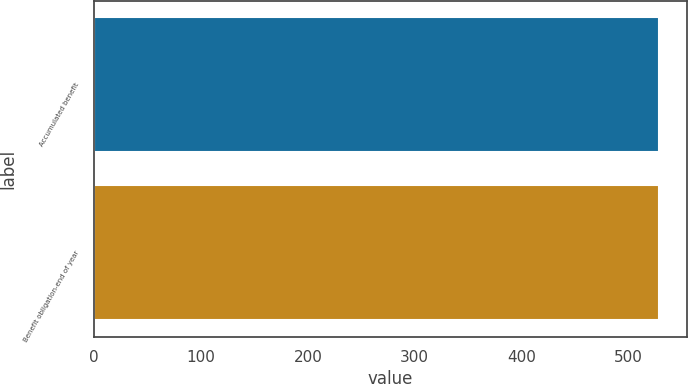<chart> <loc_0><loc_0><loc_500><loc_500><bar_chart><fcel>Accumulated benefit<fcel>Benefit obligation-end of year<nl><fcel>528<fcel>528.1<nl></chart> 